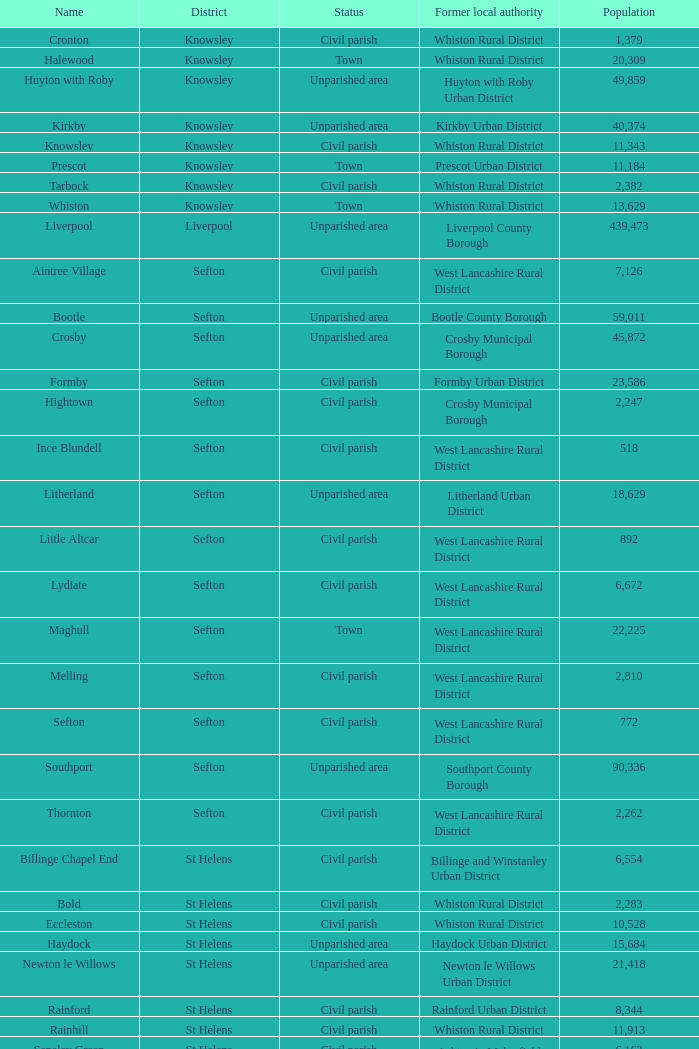What is the district of wallasey Wirral. 